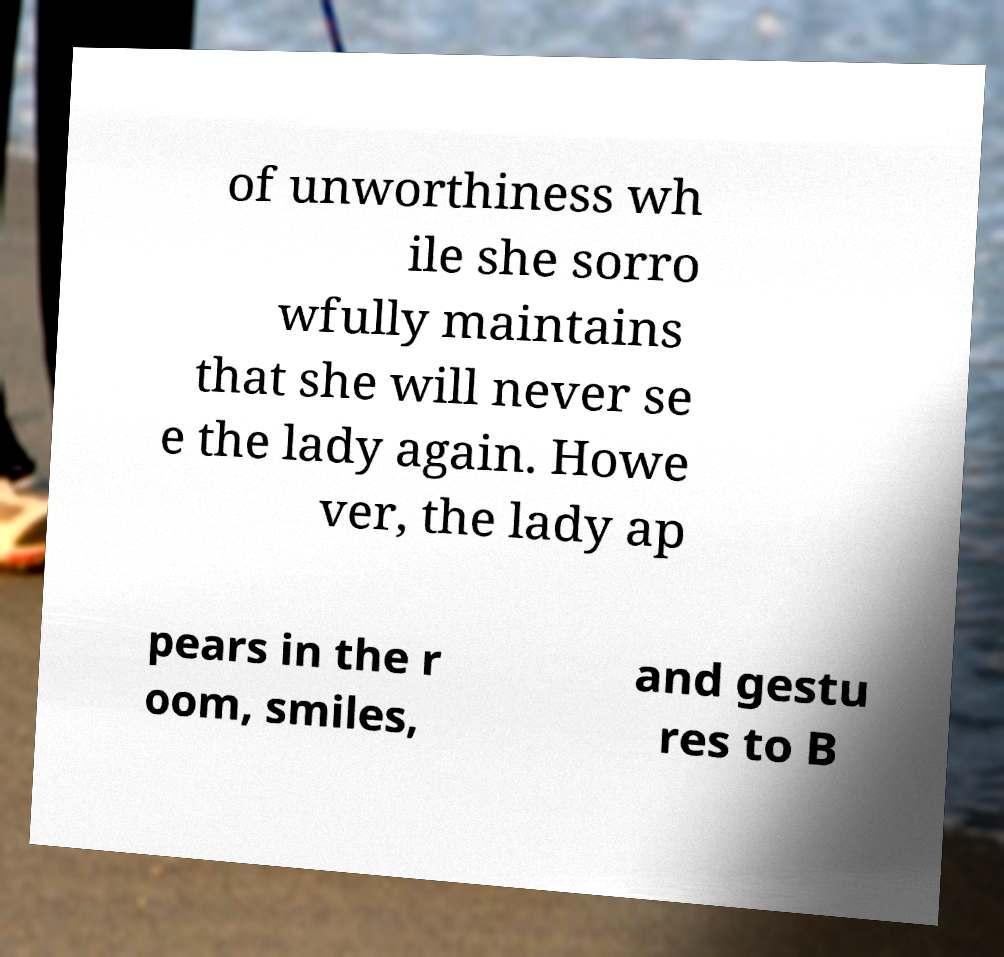I need the written content from this picture converted into text. Can you do that? of unworthiness wh ile she sorro wfully maintains that she will never se e the lady again. Howe ver, the lady ap pears in the r oom, smiles, and gestu res to B 